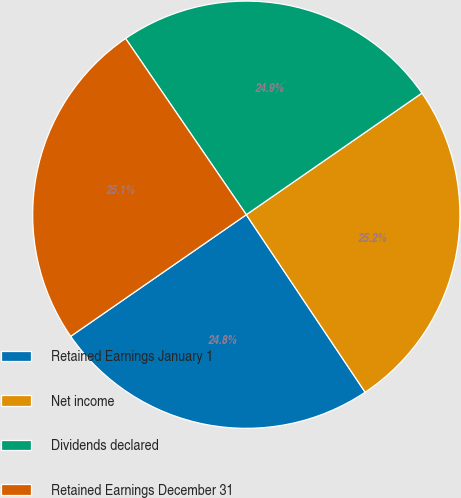Convert chart. <chart><loc_0><loc_0><loc_500><loc_500><pie_chart><fcel>Retained Earnings January 1<fcel>Net income<fcel>Dividends declared<fcel>Retained Earnings December 31<nl><fcel>24.75%<fcel>25.25%<fcel>24.92%<fcel>25.08%<nl></chart> 